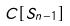Convert formula to latex. <formula><loc_0><loc_0><loc_500><loc_500>C [ S _ { n - 1 } ]</formula> 